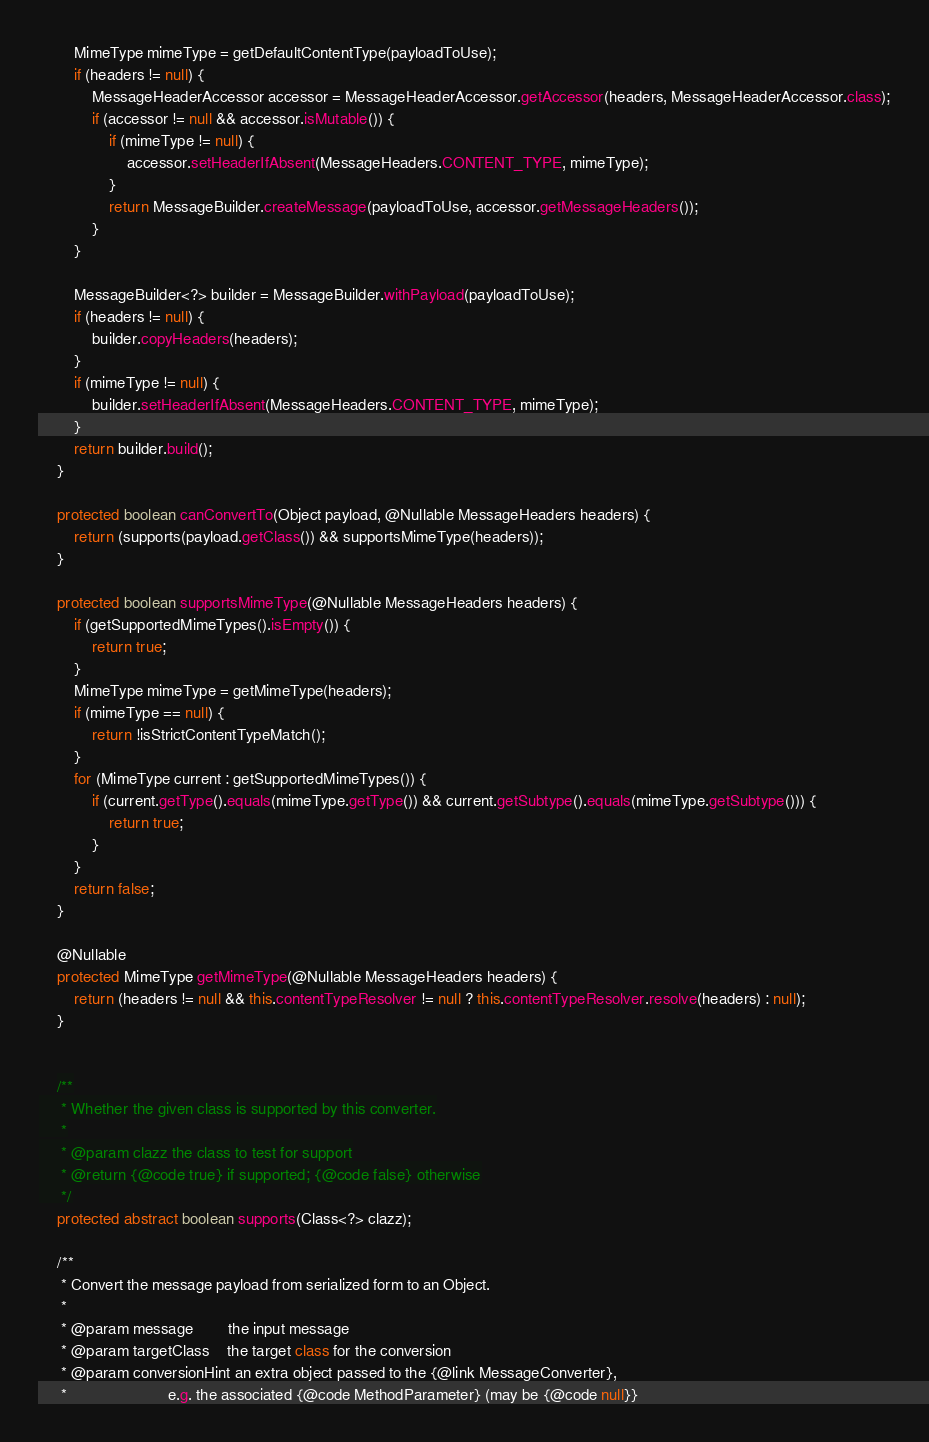<code> <loc_0><loc_0><loc_500><loc_500><_Java_>		MimeType mimeType = getDefaultContentType(payloadToUse);
		if (headers != null) {
			MessageHeaderAccessor accessor = MessageHeaderAccessor.getAccessor(headers, MessageHeaderAccessor.class);
			if (accessor != null && accessor.isMutable()) {
				if (mimeType != null) {
					accessor.setHeaderIfAbsent(MessageHeaders.CONTENT_TYPE, mimeType);
				}
				return MessageBuilder.createMessage(payloadToUse, accessor.getMessageHeaders());
			}
		}

		MessageBuilder<?> builder = MessageBuilder.withPayload(payloadToUse);
		if (headers != null) {
			builder.copyHeaders(headers);
		}
		if (mimeType != null) {
			builder.setHeaderIfAbsent(MessageHeaders.CONTENT_TYPE, mimeType);
		}
		return builder.build();
	}

	protected boolean canConvertTo(Object payload, @Nullable MessageHeaders headers) {
		return (supports(payload.getClass()) && supportsMimeType(headers));
	}

	protected boolean supportsMimeType(@Nullable MessageHeaders headers) {
		if (getSupportedMimeTypes().isEmpty()) {
			return true;
		}
		MimeType mimeType = getMimeType(headers);
		if (mimeType == null) {
			return !isStrictContentTypeMatch();
		}
		for (MimeType current : getSupportedMimeTypes()) {
			if (current.getType().equals(mimeType.getType()) && current.getSubtype().equals(mimeType.getSubtype())) {
				return true;
			}
		}
		return false;
	}

	@Nullable
	protected MimeType getMimeType(@Nullable MessageHeaders headers) {
		return (headers != null && this.contentTypeResolver != null ? this.contentTypeResolver.resolve(headers) : null);
	}


	/**
	 * Whether the given class is supported by this converter.
	 *
	 * @param clazz the class to test for support
	 * @return {@code true} if supported; {@code false} otherwise
	 */
	protected abstract boolean supports(Class<?> clazz);

	/**
	 * Convert the message payload from serialized form to an Object.
	 *
	 * @param message        the input message
	 * @param targetClass    the target class for the conversion
	 * @param conversionHint an extra object passed to the {@link MessageConverter},
	 *                       e.g. the associated {@code MethodParameter} (may be {@code null}}</code> 